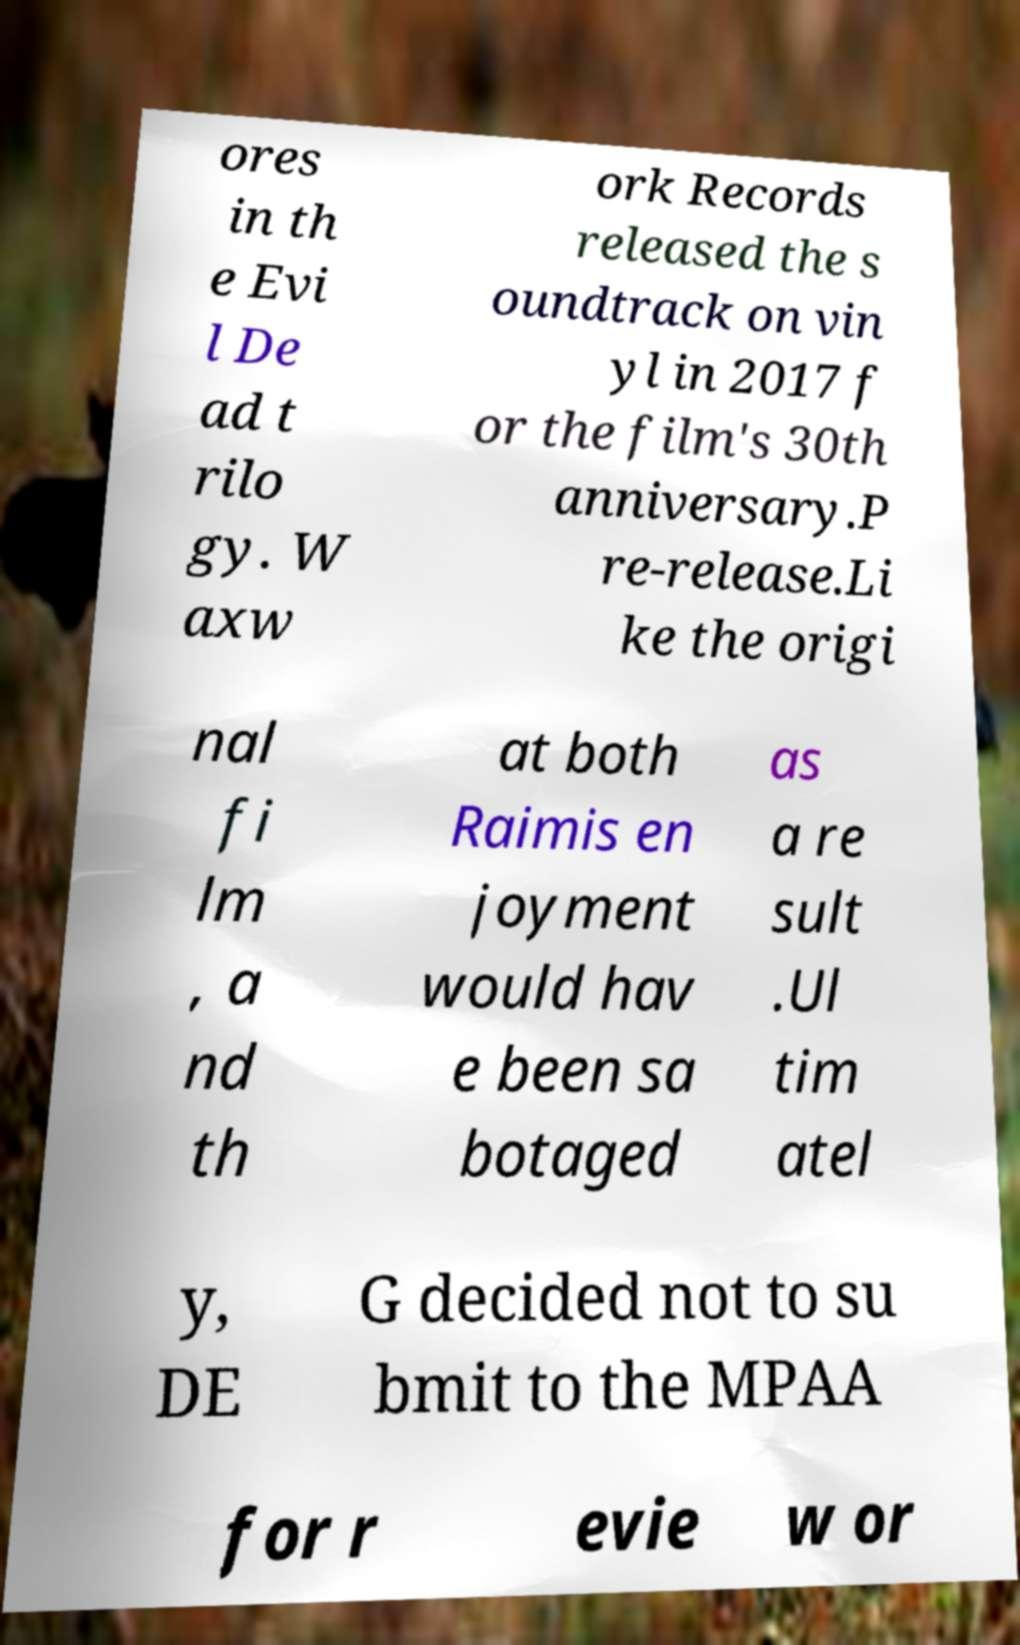Please read and relay the text visible in this image. What does it say? ores in th e Evi l De ad t rilo gy. W axw ork Records released the s oundtrack on vin yl in 2017 f or the film's 30th anniversary.P re-release.Li ke the origi nal fi lm , a nd th at both Raimis en joyment would hav e been sa botaged as a re sult .Ul tim atel y, DE G decided not to su bmit to the MPAA for r evie w or 